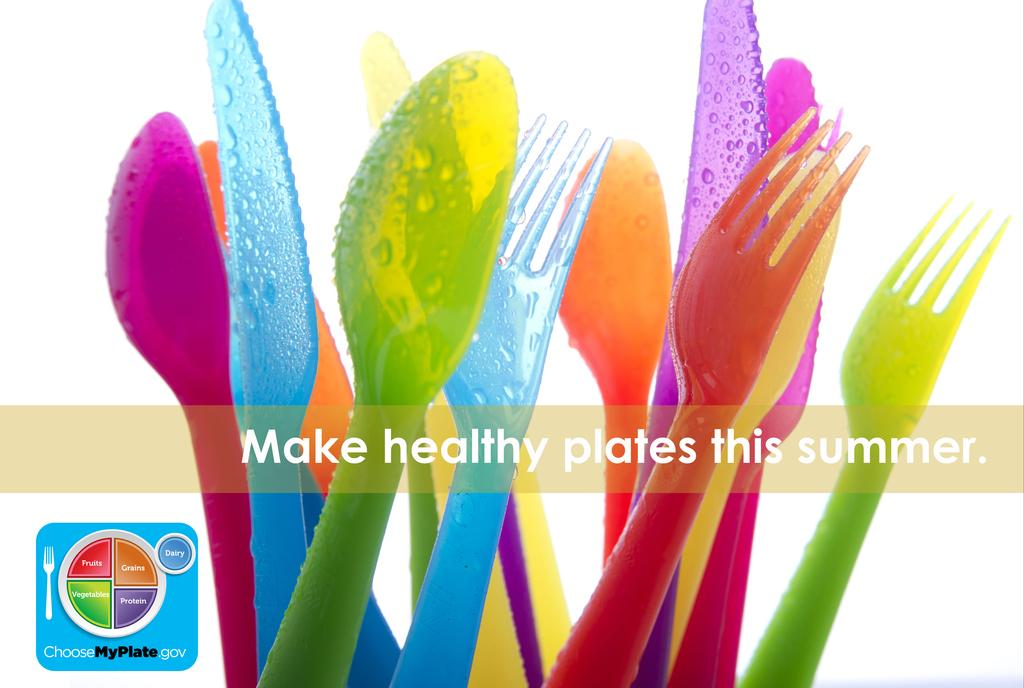What type of utensils are present in the image? There are spoons, knives, and forks in the image. What material are the utensils made of? The utensils are made of plastic. What can be observed about the colors of the utensils? The utensils have different colors. What message is written on the utensils? The message "MAKE HEALTHY PLATES THIS SUMMER" is written on the utensils. What type of mist can be seen surrounding the utensils in the image? There is no mist present in the image; it only features utensils with different colors and a message written on them. 